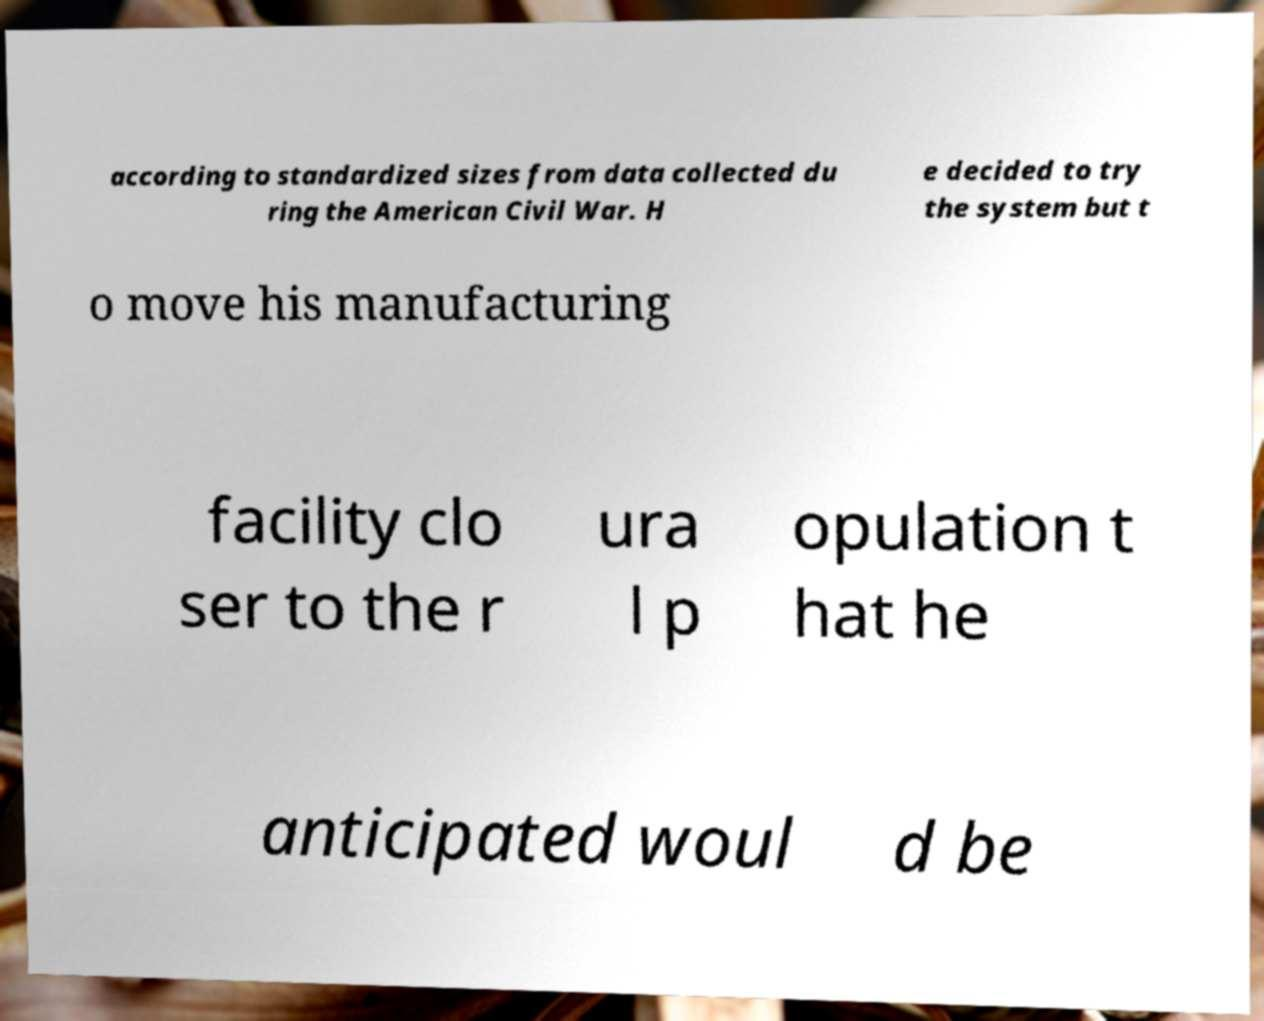There's text embedded in this image that I need extracted. Can you transcribe it verbatim? according to standardized sizes from data collected du ring the American Civil War. H e decided to try the system but t o move his manufacturing facility clo ser to the r ura l p opulation t hat he anticipated woul d be 